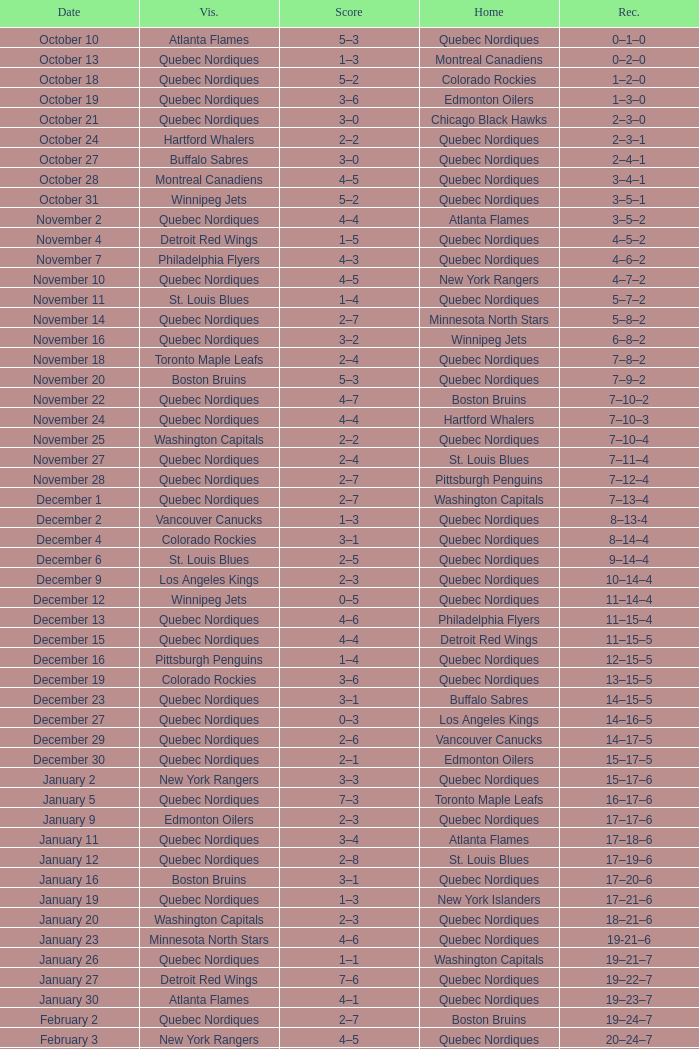Which Record has a Score of 2–4, and a Home of quebec nordiques? 7–8–2. 